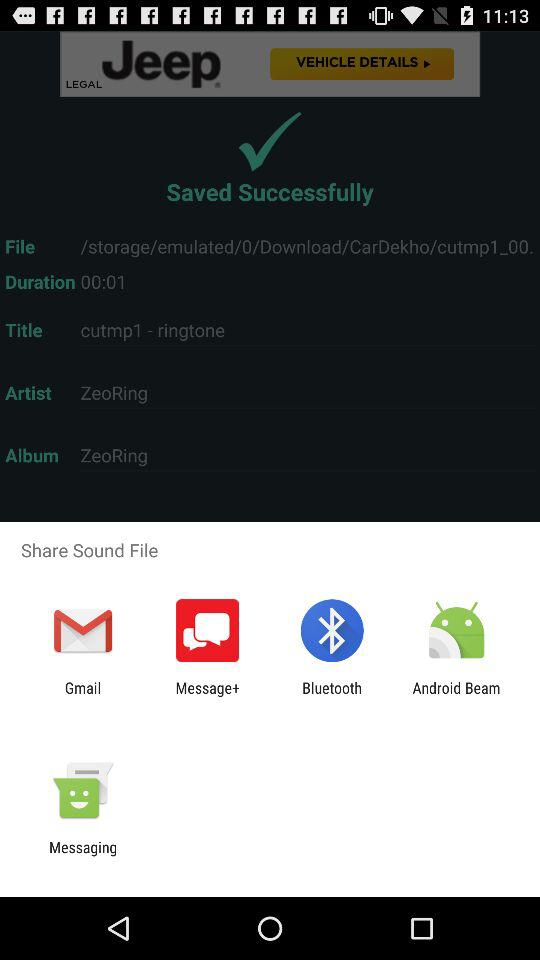Through what application can we share sound files? The applications are "Gmail", "Message+", "Bluetooth", "Android Beam" and "Messaging". 